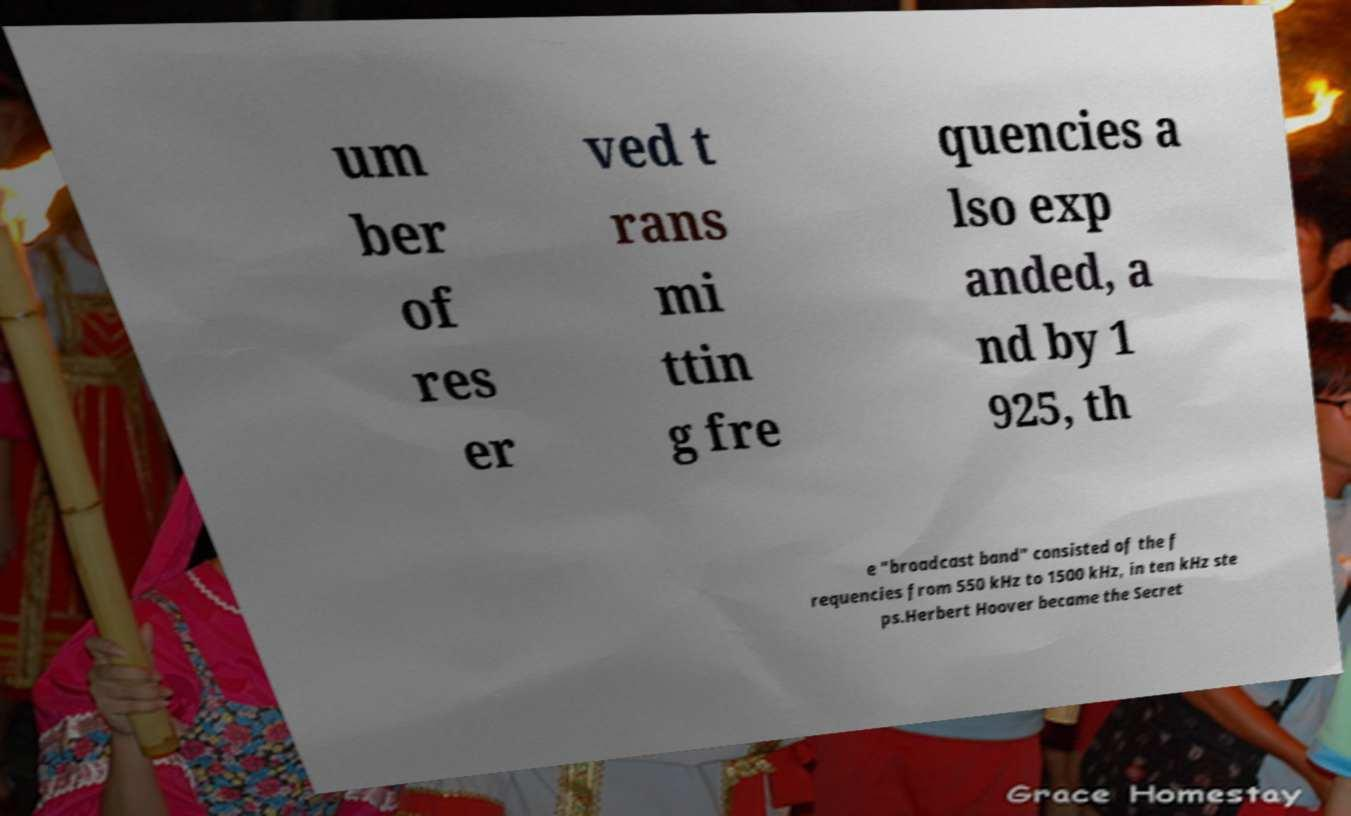What messages or text are displayed in this image? I need them in a readable, typed format. um ber of res er ved t rans mi ttin g fre quencies a lso exp anded, a nd by 1 925, th e "broadcast band" consisted of the f requencies from 550 kHz to 1500 kHz, in ten kHz ste ps.Herbert Hoover became the Secret 